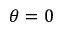<formula> <loc_0><loc_0><loc_500><loc_500>\theta = 0</formula> 